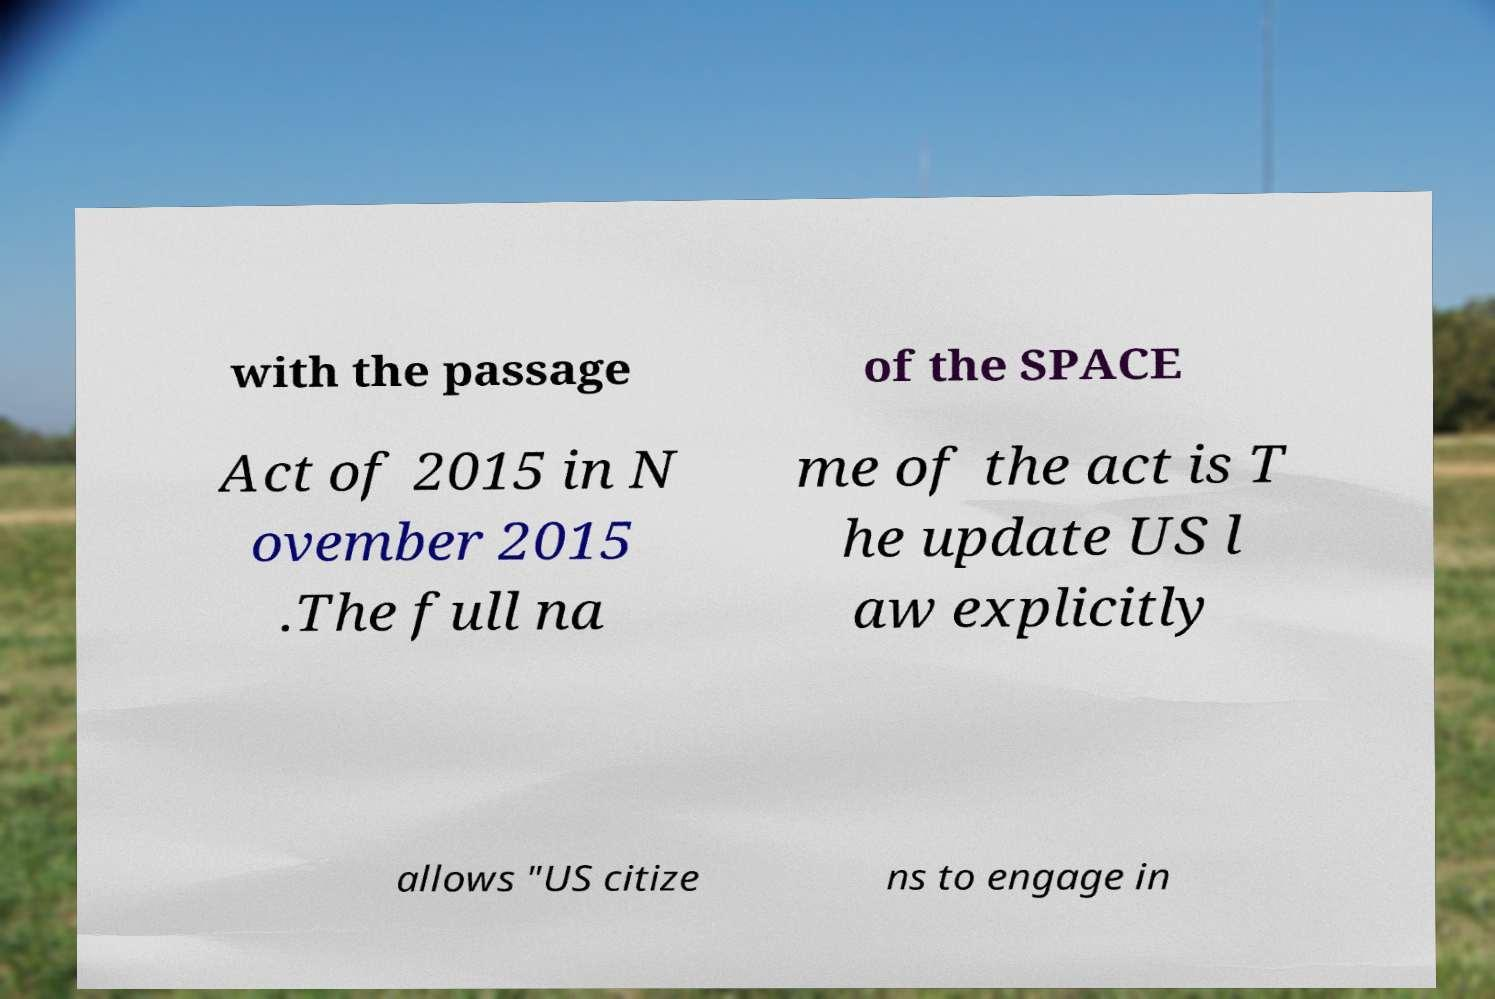For documentation purposes, I need the text within this image transcribed. Could you provide that? with the passage of the SPACE Act of 2015 in N ovember 2015 .The full na me of the act is T he update US l aw explicitly allows "US citize ns to engage in 